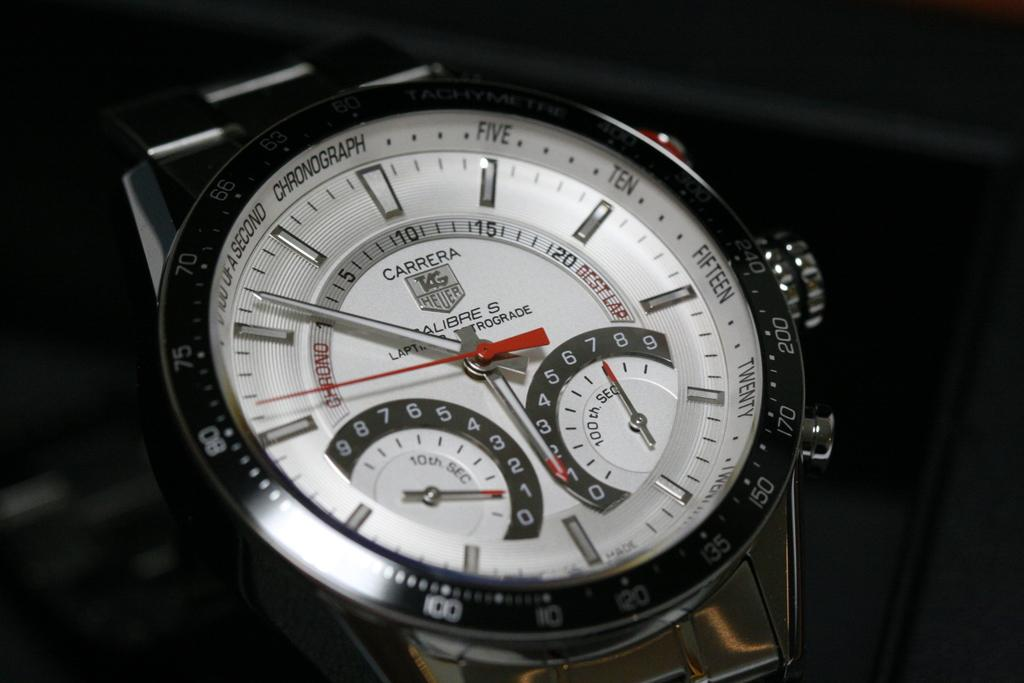Provide a one-sentence caption for the provided image. A Carrera silver watch with 5:53 on the face. 